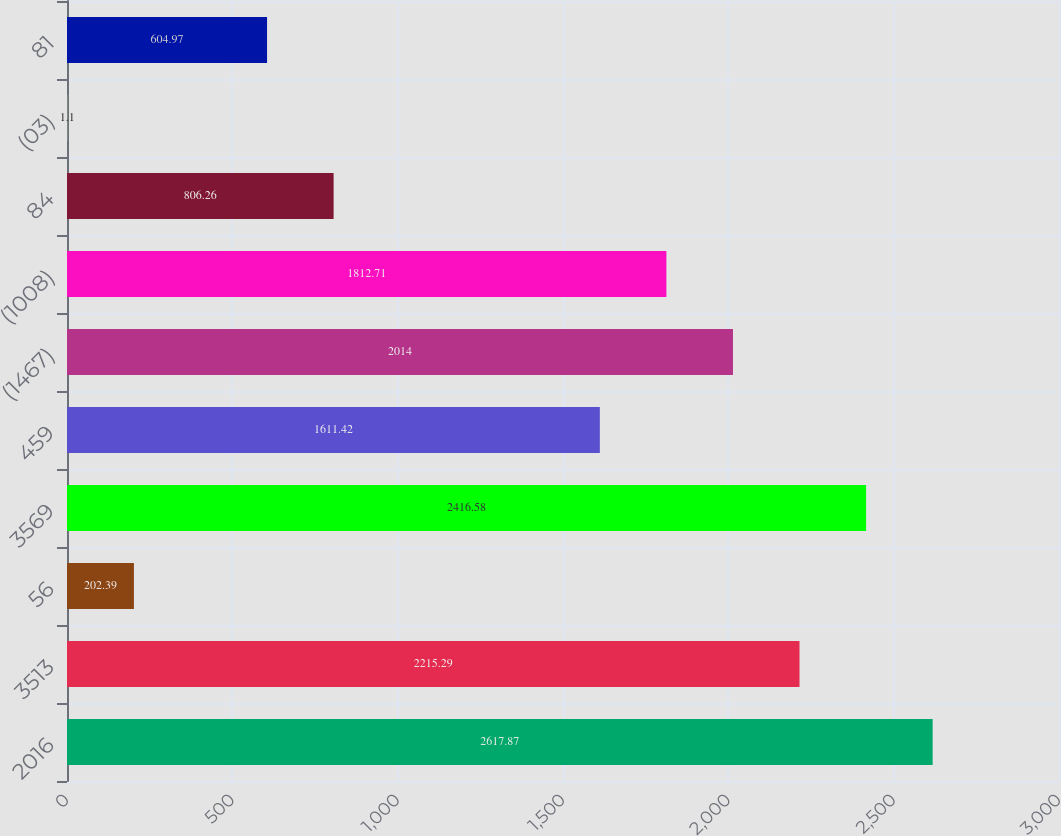Convert chart. <chart><loc_0><loc_0><loc_500><loc_500><bar_chart><fcel>2016<fcel>3513<fcel>56<fcel>3569<fcel>459<fcel>(1467)<fcel>(1008)<fcel>84<fcel>(03)<fcel>81<nl><fcel>2617.87<fcel>2215.29<fcel>202.39<fcel>2416.58<fcel>1611.42<fcel>2014<fcel>1812.71<fcel>806.26<fcel>1.1<fcel>604.97<nl></chart> 